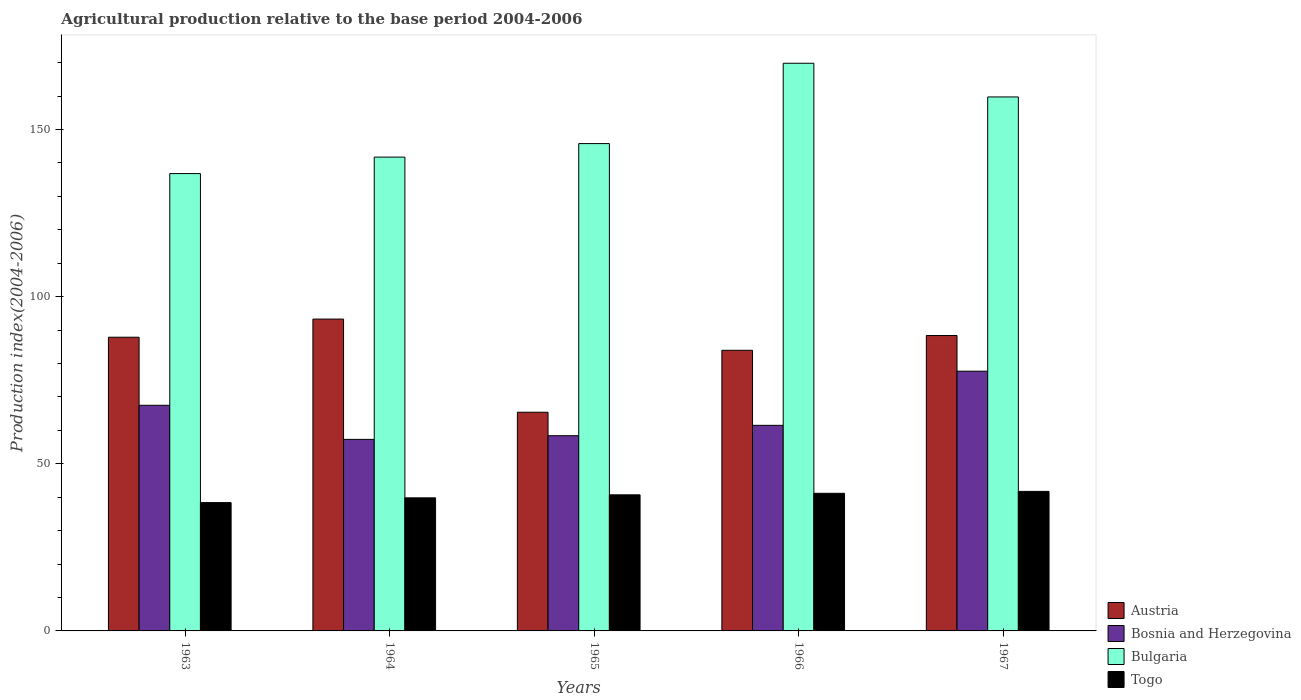How many different coloured bars are there?
Your response must be concise. 4. How many groups of bars are there?
Your response must be concise. 5. Are the number of bars per tick equal to the number of legend labels?
Offer a very short reply. Yes. How many bars are there on the 3rd tick from the right?
Your answer should be very brief. 4. What is the label of the 5th group of bars from the left?
Provide a short and direct response. 1967. In how many cases, is the number of bars for a given year not equal to the number of legend labels?
Ensure brevity in your answer.  0. What is the agricultural production index in Bulgaria in 1966?
Keep it short and to the point. 169.82. Across all years, what is the maximum agricultural production index in Austria?
Give a very brief answer. 93.29. Across all years, what is the minimum agricultural production index in Bulgaria?
Keep it short and to the point. 136.82. In which year was the agricultural production index in Bosnia and Herzegovina maximum?
Provide a succinct answer. 1967. In which year was the agricultural production index in Austria minimum?
Your answer should be compact. 1965. What is the total agricultural production index in Austria in the graph?
Keep it short and to the point. 418.89. What is the difference between the agricultural production index in Bosnia and Herzegovina in 1963 and that in 1967?
Provide a short and direct response. -10.2. What is the difference between the agricultural production index in Togo in 1966 and the agricultural production index in Bosnia and Herzegovina in 1963?
Ensure brevity in your answer.  -26.33. What is the average agricultural production index in Bulgaria per year?
Keep it short and to the point. 150.78. In the year 1967, what is the difference between the agricultural production index in Bosnia and Herzegovina and agricultural production index in Bulgaria?
Your answer should be compact. -82.04. In how many years, is the agricultural production index in Togo greater than 20?
Offer a very short reply. 5. What is the ratio of the agricultural production index in Austria in 1965 to that in 1966?
Offer a terse response. 0.78. Is the agricultural production index in Bosnia and Herzegovina in 1965 less than that in 1966?
Provide a short and direct response. Yes. What is the difference between the highest and the second highest agricultural production index in Bulgaria?
Make the answer very short. 10.08. What is the difference between the highest and the lowest agricultural production index in Bosnia and Herzegovina?
Make the answer very short. 20.4. In how many years, is the agricultural production index in Bulgaria greater than the average agricultural production index in Bulgaria taken over all years?
Give a very brief answer. 2. What does the 1st bar from the left in 1965 represents?
Offer a terse response. Austria. Is it the case that in every year, the sum of the agricultural production index in Bosnia and Herzegovina and agricultural production index in Togo is greater than the agricultural production index in Austria?
Keep it short and to the point. Yes. How many years are there in the graph?
Keep it short and to the point. 5. Are the values on the major ticks of Y-axis written in scientific E-notation?
Give a very brief answer. No. Does the graph contain any zero values?
Your answer should be very brief. No. Where does the legend appear in the graph?
Offer a terse response. Bottom right. How many legend labels are there?
Ensure brevity in your answer.  4. What is the title of the graph?
Offer a very short reply. Agricultural production relative to the base period 2004-2006. What is the label or title of the X-axis?
Your answer should be very brief. Years. What is the label or title of the Y-axis?
Your answer should be very brief. Production index(2004-2006). What is the Production index(2004-2006) of Austria in 1963?
Offer a terse response. 87.86. What is the Production index(2004-2006) of Bosnia and Herzegovina in 1963?
Provide a succinct answer. 67.5. What is the Production index(2004-2006) of Bulgaria in 1963?
Offer a very short reply. 136.82. What is the Production index(2004-2006) in Togo in 1963?
Give a very brief answer. 38.39. What is the Production index(2004-2006) of Austria in 1964?
Provide a short and direct response. 93.29. What is the Production index(2004-2006) in Bosnia and Herzegovina in 1964?
Give a very brief answer. 57.3. What is the Production index(2004-2006) of Bulgaria in 1964?
Give a very brief answer. 141.74. What is the Production index(2004-2006) in Togo in 1964?
Offer a very short reply. 39.81. What is the Production index(2004-2006) of Austria in 1965?
Your answer should be very brief. 65.42. What is the Production index(2004-2006) of Bosnia and Herzegovina in 1965?
Offer a very short reply. 58.4. What is the Production index(2004-2006) of Bulgaria in 1965?
Provide a succinct answer. 145.79. What is the Production index(2004-2006) in Togo in 1965?
Your response must be concise. 40.71. What is the Production index(2004-2006) in Austria in 1966?
Give a very brief answer. 83.95. What is the Production index(2004-2006) in Bosnia and Herzegovina in 1966?
Keep it short and to the point. 61.5. What is the Production index(2004-2006) in Bulgaria in 1966?
Ensure brevity in your answer.  169.82. What is the Production index(2004-2006) in Togo in 1966?
Offer a very short reply. 41.17. What is the Production index(2004-2006) in Austria in 1967?
Offer a terse response. 88.37. What is the Production index(2004-2006) in Bosnia and Herzegovina in 1967?
Your response must be concise. 77.7. What is the Production index(2004-2006) in Bulgaria in 1967?
Offer a very short reply. 159.74. What is the Production index(2004-2006) in Togo in 1967?
Your answer should be very brief. 41.74. Across all years, what is the maximum Production index(2004-2006) of Austria?
Offer a terse response. 93.29. Across all years, what is the maximum Production index(2004-2006) of Bosnia and Herzegovina?
Your answer should be very brief. 77.7. Across all years, what is the maximum Production index(2004-2006) in Bulgaria?
Your response must be concise. 169.82. Across all years, what is the maximum Production index(2004-2006) of Togo?
Your response must be concise. 41.74. Across all years, what is the minimum Production index(2004-2006) in Austria?
Provide a succinct answer. 65.42. Across all years, what is the minimum Production index(2004-2006) of Bosnia and Herzegovina?
Provide a succinct answer. 57.3. Across all years, what is the minimum Production index(2004-2006) of Bulgaria?
Keep it short and to the point. 136.82. Across all years, what is the minimum Production index(2004-2006) in Togo?
Provide a succinct answer. 38.39. What is the total Production index(2004-2006) of Austria in the graph?
Offer a terse response. 418.89. What is the total Production index(2004-2006) in Bosnia and Herzegovina in the graph?
Offer a terse response. 322.4. What is the total Production index(2004-2006) of Bulgaria in the graph?
Your response must be concise. 753.91. What is the total Production index(2004-2006) of Togo in the graph?
Provide a short and direct response. 201.82. What is the difference between the Production index(2004-2006) of Austria in 1963 and that in 1964?
Make the answer very short. -5.43. What is the difference between the Production index(2004-2006) of Bosnia and Herzegovina in 1963 and that in 1964?
Your answer should be very brief. 10.2. What is the difference between the Production index(2004-2006) of Bulgaria in 1963 and that in 1964?
Offer a very short reply. -4.92. What is the difference between the Production index(2004-2006) in Togo in 1963 and that in 1964?
Offer a terse response. -1.42. What is the difference between the Production index(2004-2006) in Austria in 1963 and that in 1965?
Ensure brevity in your answer.  22.44. What is the difference between the Production index(2004-2006) of Bosnia and Herzegovina in 1963 and that in 1965?
Provide a succinct answer. 9.1. What is the difference between the Production index(2004-2006) in Bulgaria in 1963 and that in 1965?
Give a very brief answer. -8.97. What is the difference between the Production index(2004-2006) of Togo in 1963 and that in 1965?
Your response must be concise. -2.32. What is the difference between the Production index(2004-2006) of Austria in 1963 and that in 1966?
Your answer should be very brief. 3.91. What is the difference between the Production index(2004-2006) in Bulgaria in 1963 and that in 1966?
Provide a short and direct response. -33. What is the difference between the Production index(2004-2006) in Togo in 1963 and that in 1966?
Offer a very short reply. -2.78. What is the difference between the Production index(2004-2006) of Austria in 1963 and that in 1967?
Your answer should be compact. -0.51. What is the difference between the Production index(2004-2006) of Bosnia and Herzegovina in 1963 and that in 1967?
Your response must be concise. -10.2. What is the difference between the Production index(2004-2006) of Bulgaria in 1963 and that in 1967?
Make the answer very short. -22.92. What is the difference between the Production index(2004-2006) in Togo in 1963 and that in 1967?
Provide a short and direct response. -3.35. What is the difference between the Production index(2004-2006) in Austria in 1964 and that in 1965?
Offer a terse response. 27.87. What is the difference between the Production index(2004-2006) of Bulgaria in 1964 and that in 1965?
Provide a short and direct response. -4.05. What is the difference between the Production index(2004-2006) of Togo in 1964 and that in 1965?
Provide a short and direct response. -0.9. What is the difference between the Production index(2004-2006) of Austria in 1964 and that in 1966?
Offer a terse response. 9.34. What is the difference between the Production index(2004-2006) in Bulgaria in 1964 and that in 1966?
Your response must be concise. -28.08. What is the difference between the Production index(2004-2006) in Togo in 1964 and that in 1966?
Offer a very short reply. -1.36. What is the difference between the Production index(2004-2006) in Austria in 1964 and that in 1967?
Provide a short and direct response. 4.92. What is the difference between the Production index(2004-2006) of Bosnia and Herzegovina in 1964 and that in 1967?
Give a very brief answer. -20.4. What is the difference between the Production index(2004-2006) of Bulgaria in 1964 and that in 1967?
Keep it short and to the point. -18. What is the difference between the Production index(2004-2006) of Togo in 1964 and that in 1967?
Ensure brevity in your answer.  -1.93. What is the difference between the Production index(2004-2006) of Austria in 1965 and that in 1966?
Keep it short and to the point. -18.53. What is the difference between the Production index(2004-2006) in Bosnia and Herzegovina in 1965 and that in 1966?
Keep it short and to the point. -3.1. What is the difference between the Production index(2004-2006) of Bulgaria in 1965 and that in 1966?
Your answer should be compact. -24.03. What is the difference between the Production index(2004-2006) of Togo in 1965 and that in 1966?
Your answer should be very brief. -0.46. What is the difference between the Production index(2004-2006) in Austria in 1965 and that in 1967?
Keep it short and to the point. -22.95. What is the difference between the Production index(2004-2006) of Bosnia and Herzegovina in 1965 and that in 1967?
Provide a succinct answer. -19.3. What is the difference between the Production index(2004-2006) in Bulgaria in 1965 and that in 1967?
Provide a succinct answer. -13.95. What is the difference between the Production index(2004-2006) of Togo in 1965 and that in 1967?
Your answer should be very brief. -1.03. What is the difference between the Production index(2004-2006) in Austria in 1966 and that in 1967?
Provide a short and direct response. -4.42. What is the difference between the Production index(2004-2006) of Bosnia and Herzegovina in 1966 and that in 1967?
Make the answer very short. -16.2. What is the difference between the Production index(2004-2006) in Bulgaria in 1966 and that in 1967?
Your answer should be compact. 10.08. What is the difference between the Production index(2004-2006) of Togo in 1966 and that in 1967?
Your response must be concise. -0.57. What is the difference between the Production index(2004-2006) of Austria in 1963 and the Production index(2004-2006) of Bosnia and Herzegovina in 1964?
Ensure brevity in your answer.  30.56. What is the difference between the Production index(2004-2006) in Austria in 1963 and the Production index(2004-2006) in Bulgaria in 1964?
Give a very brief answer. -53.88. What is the difference between the Production index(2004-2006) of Austria in 1963 and the Production index(2004-2006) of Togo in 1964?
Give a very brief answer. 48.05. What is the difference between the Production index(2004-2006) in Bosnia and Herzegovina in 1963 and the Production index(2004-2006) in Bulgaria in 1964?
Make the answer very short. -74.24. What is the difference between the Production index(2004-2006) in Bosnia and Herzegovina in 1963 and the Production index(2004-2006) in Togo in 1964?
Your answer should be very brief. 27.69. What is the difference between the Production index(2004-2006) of Bulgaria in 1963 and the Production index(2004-2006) of Togo in 1964?
Your answer should be very brief. 97.01. What is the difference between the Production index(2004-2006) of Austria in 1963 and the Production index(2004-2006) of Bosnia and Herzegovina in 1965?
Provide a short and direct response. 29.46. What is the difference between the Production index(2004-2006) in Austria in 1963 and the Production index(2004-2006) in Bulgaria in 1965?
Ensure brevity in your answer.  -57.93. What is the difference between the Production index(2004-2006) of Austria in 1963 and the Production index(2004-2006) of Togo in 1965?
Ensure brevity in your answer.  47.15. What is the difference between the Production index(2004-2006) of Bosnia and Herzegovina in 1963 and the Production index(2004-2006) of Bulgaria in 1965?
Offer a terse response. -78.29. What is the difference between the Production index(2004-2006) in Bosnia and Herzegovina in 1963 and the Production index(2004-2006) in Togo in 1965?
Keep it short and to the point. 26.79. What is the difference between the Production index(2004-2006) in Bulgaria in 1963 and the Production index(2004-2006) in Togo in 1965?
Your answer should be very brief. 96.11. What is the difference between the Production index(2004-2006) of Austria in 1963 and the Production index(2004-2006) of Bosnia and Herzegovina in 1966?
Give a very brief answer. 26.36. What is the difference between the Production index(2004-2006) of Austria in 1963 and the Production index(2004-2006) of Bulgaria in 1966?
Make the answer very short. -81.96. What is the difference between the Production index(2004-2006) of Austria in 1963 and the Production index(2004-2006) of Togo in 1966?
Give a very brief answer. 46.69. What is the difference between the Production index(2004-2006) of Bosnia and Herzegovina in 1963 and the Production index(2004-2006) of Bulgaria in 1966?
Provide a short and direct response. -102.32. What is the difference between the Production index(2004-2006) of Bosnia and Herzegovina in 1963 and the Production index(2004-2006) of Togo in 1966?
Provide a succinct answer. 26.33. What is the difference between the Production index(2004-2006) of Bulgaria in 1963 and the Production index(2004-2006) of Togo in 1966?
Give a very brief answer. 95.65. What is the difference between the Production index(2004-2006) in Austria in 1963 and the Production index(2004-2006) in Bosnia and Herzegovina in 1967?
Offer a terse response. 10.16. What is the difference between the Production index(2004-2006) of Austria in 1963 and the Production index(2004-2006) of Bulgaria in 1967?
Keep it short and to the point. -71.88. What is the difference between the Production index(2004-2006) in Austria in 1963 and the Production index(2004-2006) in Togo in 1967?
Ensure brevity in your answer.  46.12. What is the difference between the Production index(2004-2006) in Bosnia and Herzegovina in 1963 and the Production index(2004-2006) in Bulgaria in 1967?
Your response must be concise. -92.24. What is the difference between the Production index(2004-2006) in Bosnia and Herzegovina in 1963 and the Production index(2004-2006) in Togo in 1967?
Your answer should be compact. 25.76. What is the difference between the Production index(2004-2006) of Bulgaria in 1963 and the Production index(2004-2006) of Togo in 1967?
Offer a terse response. 95.08. What is the difference between the Production index(2004-2006) of Austria in 1964 and the Production index(2004-2006) of Bosnia and Herzegovina in 1965?
Your answer should be very brief. 34.89. What is the difference between the Production index(2004-2006) in Austria in 1964 and the Production index(2004-2006) in Bulgaria in 1965?
Your answer should be very brief. -52.5. What is the difference between the Production index(2004-2006) of Austria in 1964 and the Production index(2004-2006) of Togo in 1965?
Provide a short and direct response. 52.58. What is the difference between the Production index(2004-2006) of Bosnia and Herzegovina in 1964 and the Production index(2004-2006) of Bulgaria in 1965?
Your response must be concise. -88.49. What is the difference between the Production index(2004-2006) in Bosnia and Herzegovina in 1964 and the Production index(2004-2006) in Togo in 1965?
Give a very brief answer. 16.59. What is the difference between the Production index(2004-2006) in Bulgaria in 1964 and the Production index(2004-2006) in Togo in 1965?
Keep it short and to the point. 101.03. What is the difference between the Production index(2004-2006) in Austria in 1964 and the Production index(2004-2006) in Bosnia and Herzegovina in 1966?
Your answer should be very brief. 31.79. What is the difference between the Production index(2004-2006) of Austria in 1964 and the Production index(2004-2006) of Bulgaria in 1966?
Provide a succinct answer. -76.53. What is the difference between the Production index(2004-2006) in Austria in 1964 and the Production index(2004-2006) in Togo in 1966?
Your answer should be very brief. 52.12. What is the difference between the Production index(2004-2006) in Bosnia and Herzegovina in 1964 and the Production index(2004-2006) in Bulgaria in 1966?
Provide a short and direct response. -112.52. What is the difference between the Production index(2004-2006) of Bosnia and Herzegovina in 1964 and the Production index(2004-2006) of Togo in 1966?
Offer a terse response. 16.13. What is the difference between the Production index(2004-2006) in Bulgaria in 1964 and the Production index(2004-2006) in Togo in 1966?
Keep it short and to the point. 100.57. What is the difference between the Production index(2004-2006) in Austria in 1964 and the Production index(2004-2006) in Bosnia and Herzegovina in 1967?
Your answer should be very brief. 15.59. What is the difference between the Production index(2004-2006) in Austria in 1964 and the Production index(2004-2006) in Bulgaria in 1967?
Your answer should be compact. -66.45. What is the difference between the Production index(2004-2006) in Austria in 1964 and the Production index(2004-2006) in Togo in 1967?
Your answer should be very brief. 51.55. What is the difference between the Production index(2004-2006) in Bosnia and Herzegovina in 1964 and the Production index(2004-2006) in Bulgaria in 1967?
Offer a very short reply. -102.44. What is the difference between the Production index(2004-2006) of Bosnia and Herzegovina in 1964 and the Production index(2004-2006) of Togo in 1967?
Your answer should be very brief. 15.56. What is the difference between the Production index(2004-2006) in Bulgaria in 1964 and the Production index(2004-2006) in Togo in 1967?
Your answer should be very brief. 100. What is the difference between the Production index(2004-2006) of Austria in 1965 and the Production index(2004-2006) of Bosnia and Herzegovina in 1966?
Provide a short and direct response. 3.92. What is the difference between the Production index(2004-2006) in Austria in 1965 and the Production index(2004-2006) in Bulgaria in 1966?
Your response must be concise. -104.4. What is the difference between the Production index(2004-2006) in Austria in 1965 and the Production index(2004-2006) in Togo in 1966?
Offer a very short reply. 24.25. What is the difference between the Production index(2004-2006) of Bosnia and Herzegovina in 1965 and the Production index(2004-2006) of Bulgaria in 1966?
Keep it short and to the point. -111.42. What is the difference between the Production index(2004-2006) of Bosnia and Herzegovina in 1965 and the Production index(2004-2006) of Togo in 1966?
Offer a terse response. 17.23. What is the difference between the Production index(2004-2006) in Bulgaria in 1965 and the Production index(2004-2006) in Togo in 1966?
Offer a very short reply. 104.62. What is the difference between the Production index(2004-2006) in Austria in 1965 and the Production index(2004-2006) in Bosnia and Herzegovina in 1967?
Your answer should be very brief. -12.28. What is the difference between the Production index(2004-2006) of Austria in 1965 and the Production index(2004-2006) of Bulgaria in 1967?
Ensure brevity in your answer.  -94.32. What is the difference between the Production index(2004-2006) in Austria in 1965 and the Production index(2004-2006) in Togo in 1967?
Your answer should be very brief. 23.68. What is the difference between the Production index(2004-2006) in Bosnia and Herzegovina in 1965 and the Production index(2004-2006) in Bulgaria in 1967?
Your answer should be compact. -101.34. What is the difference between the Production index(2004-2006) in Bosnia and Herzegovina in 1965 and the Production index(2004-2006) in Togo in 1967?
Give a very brief answer. 16.66. What is the difference between the Production index(2004-2006) in Bulgaria in 1965 and the Production index(2004-2006) in Togo in 1967?
Give a very brief answer. 104.05. What is the difference between the Production index(2004-2006) in Austria in 1966 and the Production index(2004-2006) in Bosnia and Herzegovina in 1967?
Provide a succinct answer. 6.25. What is the difference between the Production index(2004-2006) in Austria in 1966 and the Production index(2004-2006) in Bulgaria in 1967?
Provide a succinct answer. -75.79. What is the difference between the Production index(2004-2006) of Austria in 1966 and the Production index(2004-2006) of Togo in 1967?
Provide a succinct answer. 42.21. What is the difference between the Production index(2004-2006) in Bosnia and Herzegovina in 1966 and the Production index(2004-2006) in Bulgaria in 1967?
Provide a succinct answer. -98.24. What is the difference between the Production index(2004-2006) of Bosnia and Herzegovina in 1966 and the Production index(2004-2006) of Togo in 1967?
Offer a very short reply. 19.76. What is the difference between the Production index(2004-2006) in Bulgaria in 1966 and the Production index(2004-2006) in Togo in 1967?
Keep it short and to the point. 128.08. What is the average Production index(2004-2006) of Austria per year?
Provide a succinct answer. 83.78. What is the average Production index(2004-2006) of Bosnia and Herzegovina per year?
Give a very brief answer. 64.48. What is the average Production index(2004-2006) of Bulgaria per year?
Give a very brief answer. 150.78. What is the average Production index(2004-2006) in Togo per year?
Give a very brief answer. 40.36. In the year 1963, what is the difference between the Production index(2004-2006) of Austria and Production index(2004-2006) of Bosnia and Herzegovina?
Offer a terse response. 20.36. In the year 1963, what is the difference between the Production index(2004-2006) of Austria and Production index(2004-2006) of Bulgaria?
Ensure brevity in your answer.  -48.96. In the year 1963, what is the difference between the Production index(2004-2006) in Austria and Production index(2004-2006) in Togo?
Your response must be concise. 49.47. In the year 1963, what is the difference between the Production index(2004-2006) in Bosnia and Herzegovina and Production index(2004-2006) in Bulgaria?
Make the answer very short. -69.32. In the year 1963, what is the difference between the Production index(2004-2006) of Bosnia and Herzegovina and Production index(2004-2006) of Togo?
Offer a terse response. 29.11. In the year 1963, what is the difference between the Production index(2004-2006) of Bulgaria and Production index(2004-2006) of Togo?
Give a very brief answer. 98.43. In the year 1964, what is the difference between the Production index(2004-2006) of Austria and Production index(2004-2006) of Bosnia and Herzegovina?
Offer a very short reply. 35.99. In the year 1964, what is the difference between the Production index(2004-2006) of Austria and Production index(2004-2006) of Bulgaria?
Ensure brevity in your answer.  -48.45. In the year 1964, what is the difference between the Production index(2004-2006) in Austria and Production index(2004-2006) in Togo?
Your response must be concise. 53.48. In the year 1964, what is the difference between the Production index(2004-2006) of Bosnia and Herzegovina and Production index(2004-2006) of Bulgaria?
Your response must be concise. -84.44. In the year 1964, what is the difference between the Production index(2004-2006) of Bosnia and Herzegovina and Production index(2004-2006) of Togo?
Provide a short and direct response. 17.49. In the year 1964, what is the difference between the Production index(2004-2006) of Bulgaria and Production index(2004-2006) of Togo?
Ensure brevity in your answer.  101.93. In the year 1965, what is the difference between the Production index(2004-2006) of Austria and Production index(2004-2006) of Bosnia and Herzegovina?
Offer a very short reply. 7.02. In the year 1965, what is the difference between the Production index(2004-2006) of Austria and Production index(2004-2006) of Bulgaria?
Give a very brief answer. -80.37. In the year 1965, what is the difference between the Production index(2004-2006) of Austria and Production index(2004-2006) of Togo?
Offer a very short reply. 24.71. In the year 1965, what is the difference between the Production index(2004-2006) in Bosnia and Herzegovina and Production index(2004-2006) in Bulgaria?
Your answer should be compact. -87.39. In the year 1965, what is the difference between the Production index(2004-2006) of Bosnia and Herzegovina and Production index(2004-2006) of Togo?
Make the answer very short. 17.69. In the year 1965, what is the difference between the Production index(2004-2006) in Bulgaria and Production index(2004-2006) in Togo?
Provide a short and direct response. 105.08. In the year 1966, what is the difference between the Production index(2004-2006) in Austria and Production index(2004-2006) in Bosnia and Herzegovina?
Ensure brevity in your answer.  22.45. In the year 1966, what is the difference between the Production index(2004-2006) of Austria and Production index(2004-2006) of Bulgaria?
Keep it short and to the point. -85.87. In the year 1966, what is the difference between the Production index(2004-2006) of Austria and Production index(2004-2006) of Togo?
Give a very brief answer. 42.78. In the year 1966, what is the difference between the Production index(2004-2006) in Bosnia and Herzegovina and Production index(2004-2006) in Bulgaria?
Provide a succinct answer. -108.32. In the year 1966, what is the difference between the Production index(2004-2006) in Bosnia and Herzegovina and Production index(2004-2006) in Togo?
Provide a succinct answer. 20.33. In the year 1966, what is the difference between the Production index(2004-2006) in Bulgaria and Production index(2004-2006) in Togo?
Give a very brief answer. 128.65. In the year 1967, what is the difference between the Production index(2004-2006) in Austria and Production index(2004-2006) in Bosnia and Herzegovina?
Give a very brief answer. 10.67. In the year 1967, what is the difference between the Production index(2004-2006) of Austria and Production index(2004-2006) of Bulgaria?
Your response must be concise. -71.37. In the year 1967, what is the difference between the Production index(2004-2006) of Austria and Production index(2004-2006) of Togo?
Make the answer very short. 46.63. In the year 1967, what is the difference between the Production index(2004-2006) of Bosnia and Herzegovina and Production index(2004-2006) of Bulgaria?
Give a very brief answer. -82.04. In the year 1967, what is the difference between the Production index(2004-2006) of Bosnia and Herzegovina and Production index(2004-2006) of Togo?
Make the answer very short. 35.96. In the year 1967, what is the difference between the Production index(2004-2006) in Bulgaria and Production index(2004-2006) in Togo?
Keep it short and to the point. 118. What is the ratio of the Production index(2004-2006) of Austria in 1963 to that in 1964?
Make the answer very short. 0.94. What is the ratio of the Production index(2004-2006) of Bosnia and Herzegovina in 1963 to that in 1964?
Your answer should be very brief. 1.18. What is the ratio of the Production index(2004-2006) in Bulgaria in 1963 to that in 1964?
Ensure brevity in your answer.  0.97. What is the ratio of the Production index(2004-2006) of Togo in 1963 to that in 1964?
Make the answer very short. 0.96. What is the ratio of the Production index(2004-2006) in Austria in 1963 to that in 1965?
Provide a succinct answer. 1.34. What is the ratio of the Production index(2004-2006) of Bosnia and Herzegovina in 1963 to that in 1965?
Give a very brief answer. 1.16. What is the ratio of the Production index(2004-2006) of Bulgaria in 1963 to that in 1965?
Provide a short and direct response. 0.94. What is the ratio of the Production index(2004-2006) in Togo in 1963 to that in 1965?
Keep it short and to the point. 0.94. What is the ratio of the Production index(2004-2006) in Austria in 1963 to that in 1966?
Give a very brief answer. 1.05. What is the ratio of the Production index(2004-2006) in Bosnia and Herzegovina in 1963 to that in 1966?
Offer a terse response. 1.1. What is the ratio of the Production index(2004-2006) of Bulgaria in 1963 to that in 1966?
Provide a succinct answer. 0.81. What is the ratio of the Production index(2004-2006) in Togo in 1963 to that in 1966?
Offer a very short reply. 0.93. What is the ratio of the Production index(2004-2006) in Austria in 1963 to that in 1967?
Make the answer very short. 0.99. What is the ratio of the Production index(2004-2006) in Bosnia and Herzegovina in 1963 to that in 1967?
Your answer should be compact. 0.87. What is the ratio of the Production index(2004-2006) in Bulgaria in 1963 to that in 1967?
Provide a succinct answer. 0.86. What is the ratio of the Production index(2004-2006) of Togo in 1963 to that in 1967?
Give a very brief answer. 0.92. What is the ratio of the Production index(2004-2006) of Austria in 1964 to that in 1965?
Provide a short and direct response. 1.43. What is the ratio of the Production index(2004-2006) of Bosnia and Herzegovina in 1964 to that in 1965?
Offer a very short reply. 0.98. What is the ratio of the Production index(2004-2006) of Bulgaria in 1964 to that in 1965?
Your response must be concise. 0.97. What is the ratio of the Production index(2004-2006) in Togo in 1964 to that in 1965?
Provide a succinct answer. 0.98. What is the ratio of the Production index(2004-2006) of Austria in 1964 to that in 1966?
Provide a succinct answer. 1.11. What is the ratio of the Production index(2004-2006) in Bosnia and Herzegovina in 1964 to that in 1966?
Make the answer very short. 0.93. What is the ratio of the Production index(2004-2006) of Bulgaria in 1964 to that in 1966?
Keep it short and to the point. 0.83. What is the ratio of the Production index(2004-2006) of Togo in 1964 to that in 1966?
Ensure brevity in your answer.  0.97. What is the ratio of the Production index(2004-2006) of Austria in 1964 to that in 1967?
Provide a succinct answer. 1.06. What is the ratio of the Production index(2004-2006) of Bosnia and Herzegovina in 1964 to that in 1967?
Offer a very short reply. 0.74. What is the ratio of the Production index(2004-2006) of Bulgaria in 1964 to that in 1967?
Your answer should be compact. 0.89. What is the ratio of the Production index(2004-2006) of Togo in 1964 to that in 1967?
Provide a short and direct response. 0.95. What is the ratio of the Production index(2004-2006) in Austria in 1965 to that in 1966?
Provide a succinct answer. 0.78. What is the ratio of the Production index(2004-2006) of Bosnia and Herzegovina in 1965 to that in 1966?
Keep it short and to the point. 0.95. What is the ratio of the Production index(2004-2006) in Bulgaria in 1965 to that in 1966?
Keep it short and to the point. 0.86. What is the ratio of the Production index(2004-2006) in Austria in 1965 to that in 1967?
Your answer should be compact. 0.74. What is the ratio of the Production index(2004-2006) in Bosnia and Herzegovina in 1965 to that in 1967?
Your answer should be compact. 0.75. What is the ratio of the Production index(2004-2006) in Bulgaria in 1965 to that in 1967?
Ensure brevity in your answer.  0.91. What is the ratio of the Production index(2004-2006) of Togo in 1965 to that in 1967?
Provide a short and direct response. 0.98. What is the ratio of the Production index(2004-2006) of Bosnia and Herzegovina in 1966 to that in 1967?
Give a very brief answer. 0.79. What is the ratio of the Production index(2004-2006) of Bulgaria in 1966 to that in 1967?
Your answer should be very brief. 1.06. What is the ratio of the Production index(2004-2006) of Togo in 1966 to that in 1967?
Offer a very short reply. 0.99. What is the difference between the highest and the second highest Production index(2004-2006) in Austria?
Ensure brevity in your answer.  4.92. What is the difference between the highest and the second highest Production index(2004-2006) in Bosnia and Herzegovina?
Your response must be concise. 10.2. What is the difference between the highest and the second highest Production index(2004-2006) of Bulgaria?
Your response must be concise. 10.08. What is the difference between the highest and the second highest Production index(2004-2006) of Togo?
Your answer should be very brief. 0.57. What is the difference between the highest and the lowest Production index(2004-2006) in Austria?
Offer a terse response. 27.87. What is the difference between the highest and the lowest Production index(2004-2006) in Bosnia and Herzegovina?
Keep it short and to the point. 20.4. What is the difference between the highest and the lowest Production index(2004-2006) of Togo?
Keep it short and to the point. 3.35. 